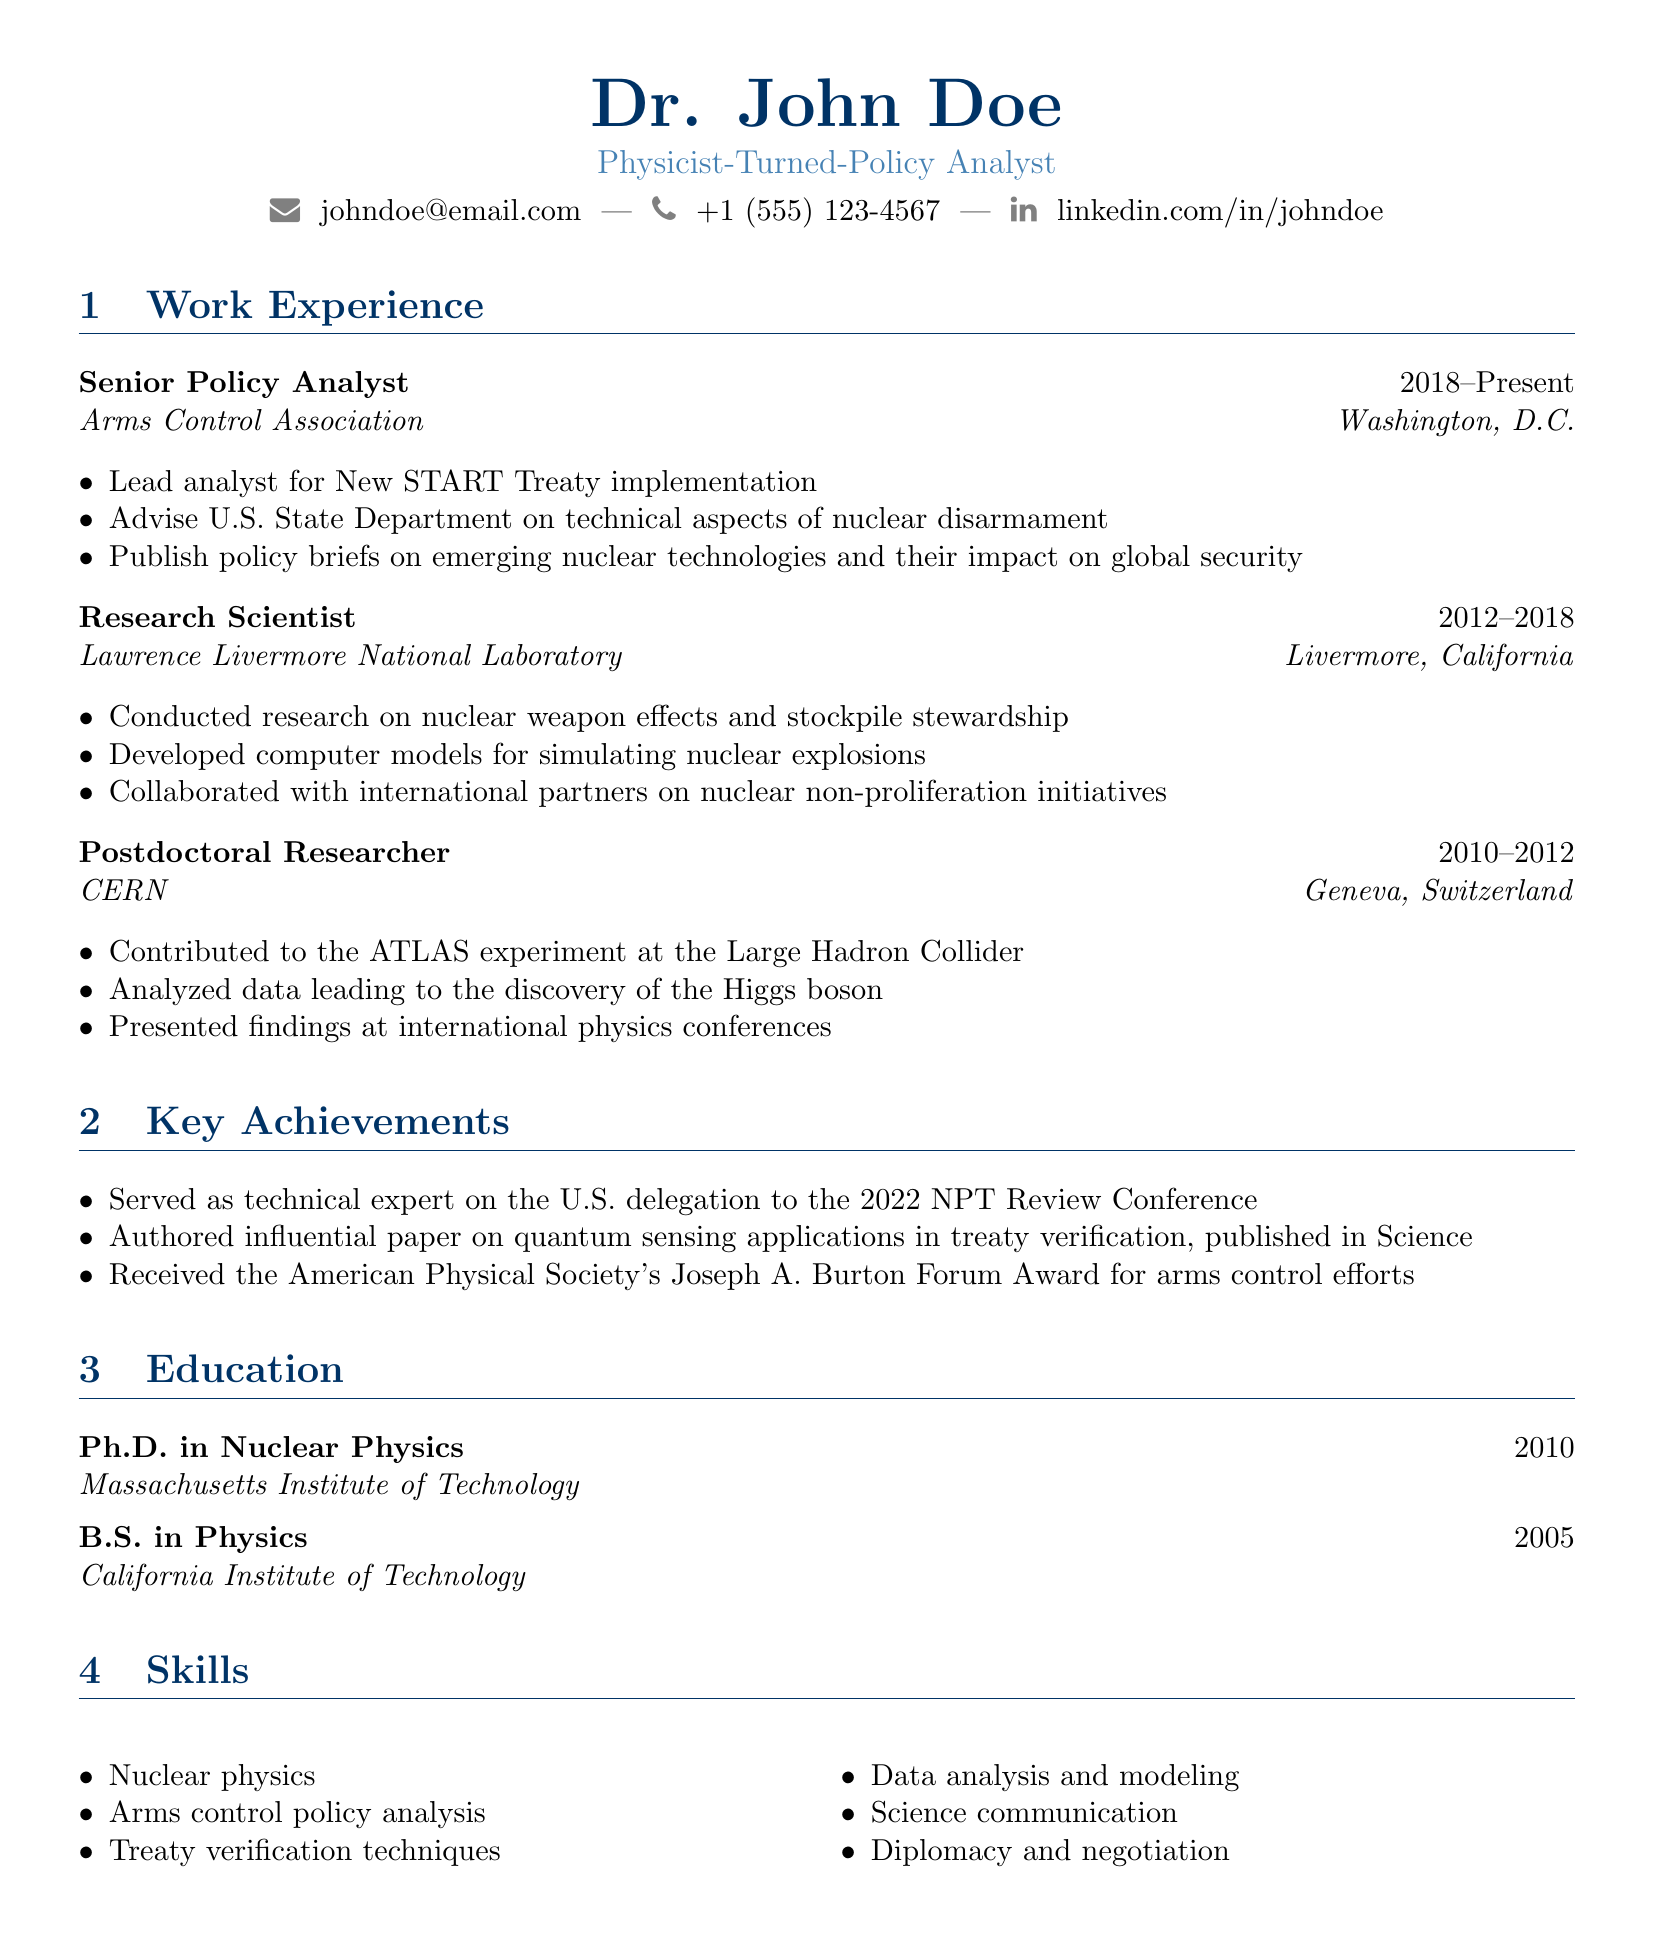What is the current position held? The current position is listed at the top of the work experience section.
Answer: Senior Policy Analyst Which organization is associated with the current position? The organization for the current position is mentioned directly after the title.
Answer: Arms Control Association What degree was awarded in 2010? The degree is stated in the education section and includes the name of the institution.
Answer: Ph.D. in Nuclear Physics What was a key achievement in 2022? The key achievement includes the specific event and year mentioned in the achievements section.
Answer: Served as technical expert on the U.S. delegation to the 2022 NPT Review Conference Which laboratory did the Research Scientist work at? The laboratory is listed under the work experience section associated with that position.
Answer: Lawrence Livermore National Laboratory What initiative was collaborated on during the Research Scientist role? The initiative relates to the responsibilities outlined in the work experience section.
Answer: Nuclear non-proliferation initiatives What two skills are listed in the skills section? The skills are enumerated in the skills section, and several are mentioned.
Answer: Nuclear physics, arms control policy analysis Which university awarded the Bachelor's degree? The institution that awarded the Bachelor’s degree is specified in the education section.
Answer: California Institute of Technology Which award was received for arms control efforts? The award is presented in the achievements section, specifying the purpose of the award.
Answer: Joseph A. Burton Forum Award 